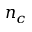Convert formula to latex. <formula><loc_0><loc_0><loc_500><loc_500>n _ { c }</formula> 